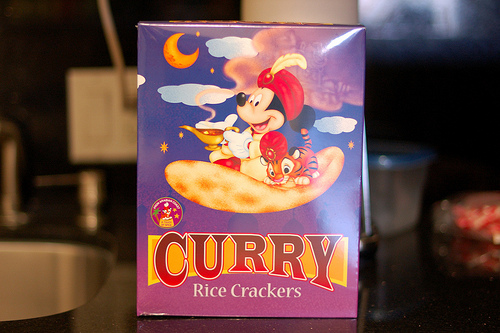<image>
Can you confirm if the crackers is above the table? No. The crackers is not positioned above the table. The vertical arrangement shows a different relationship. 